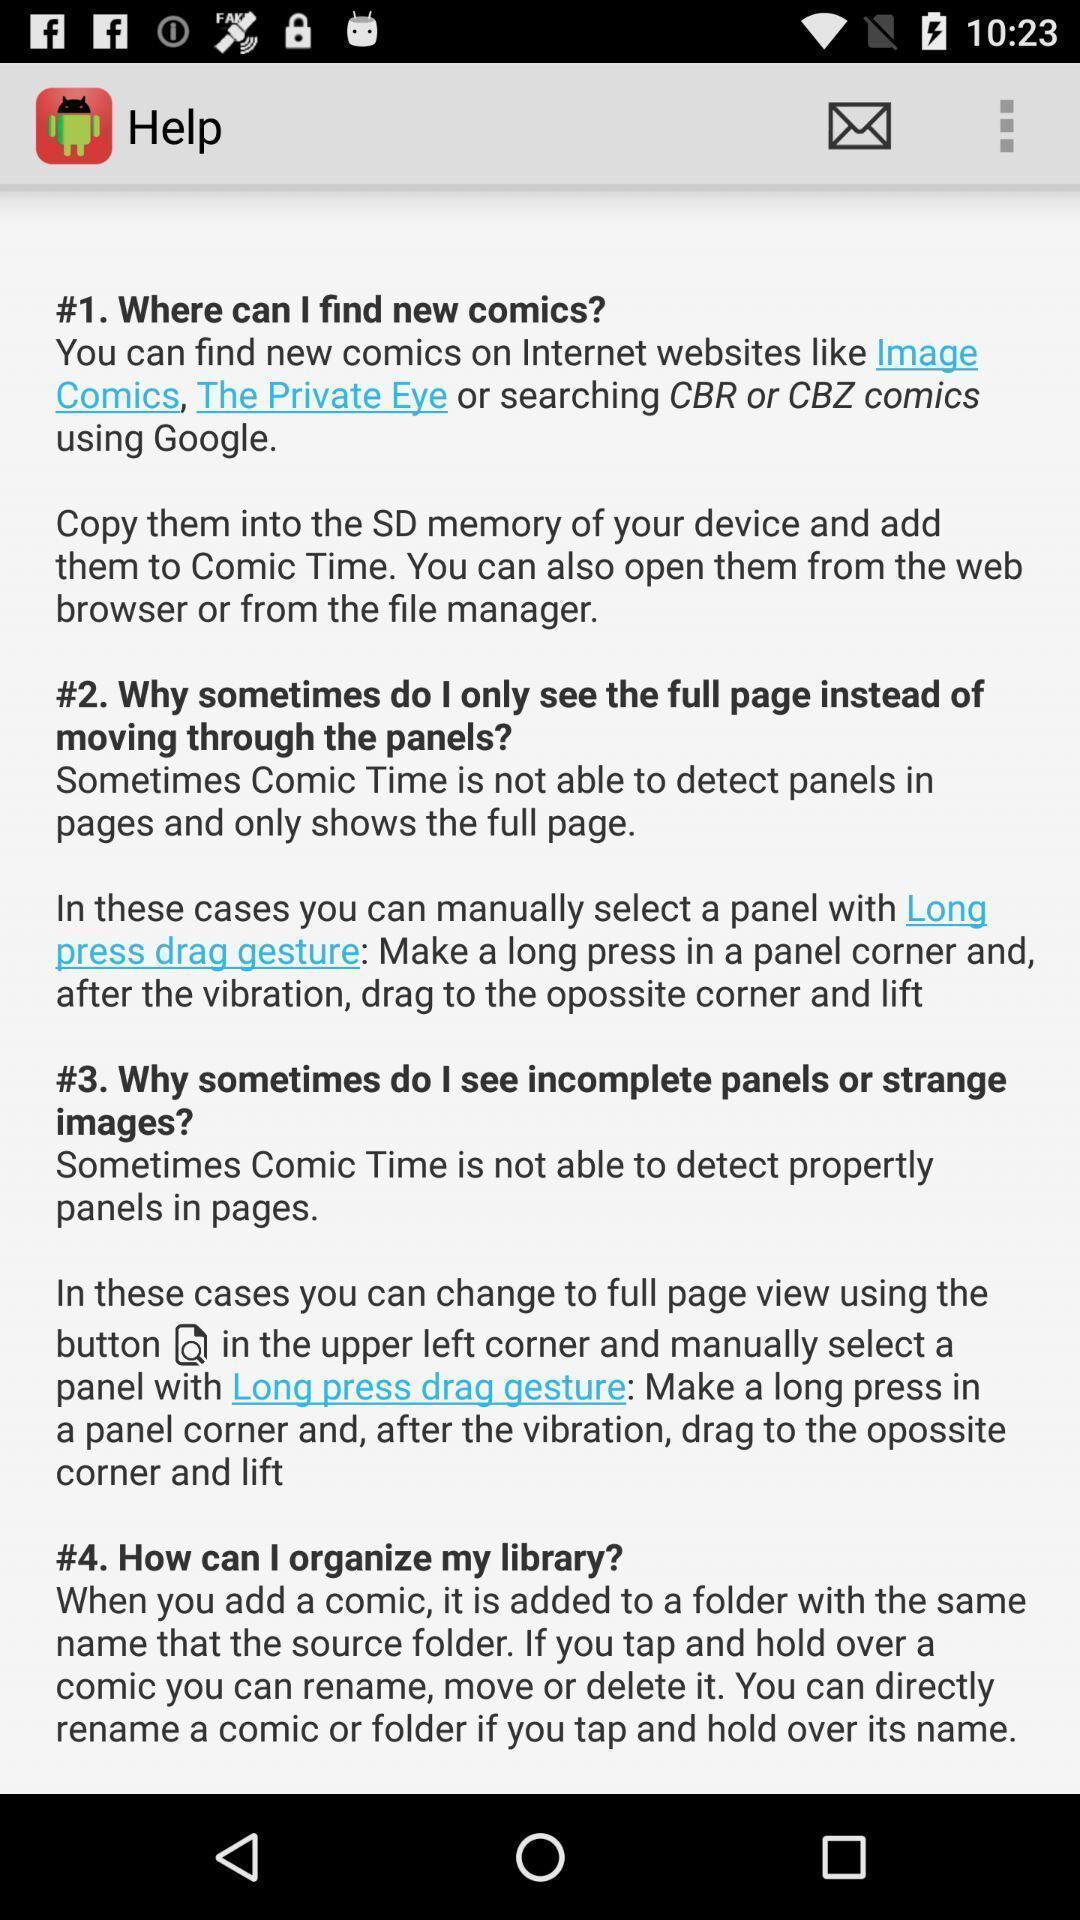Describe the content in this image. Screen shows help details. 